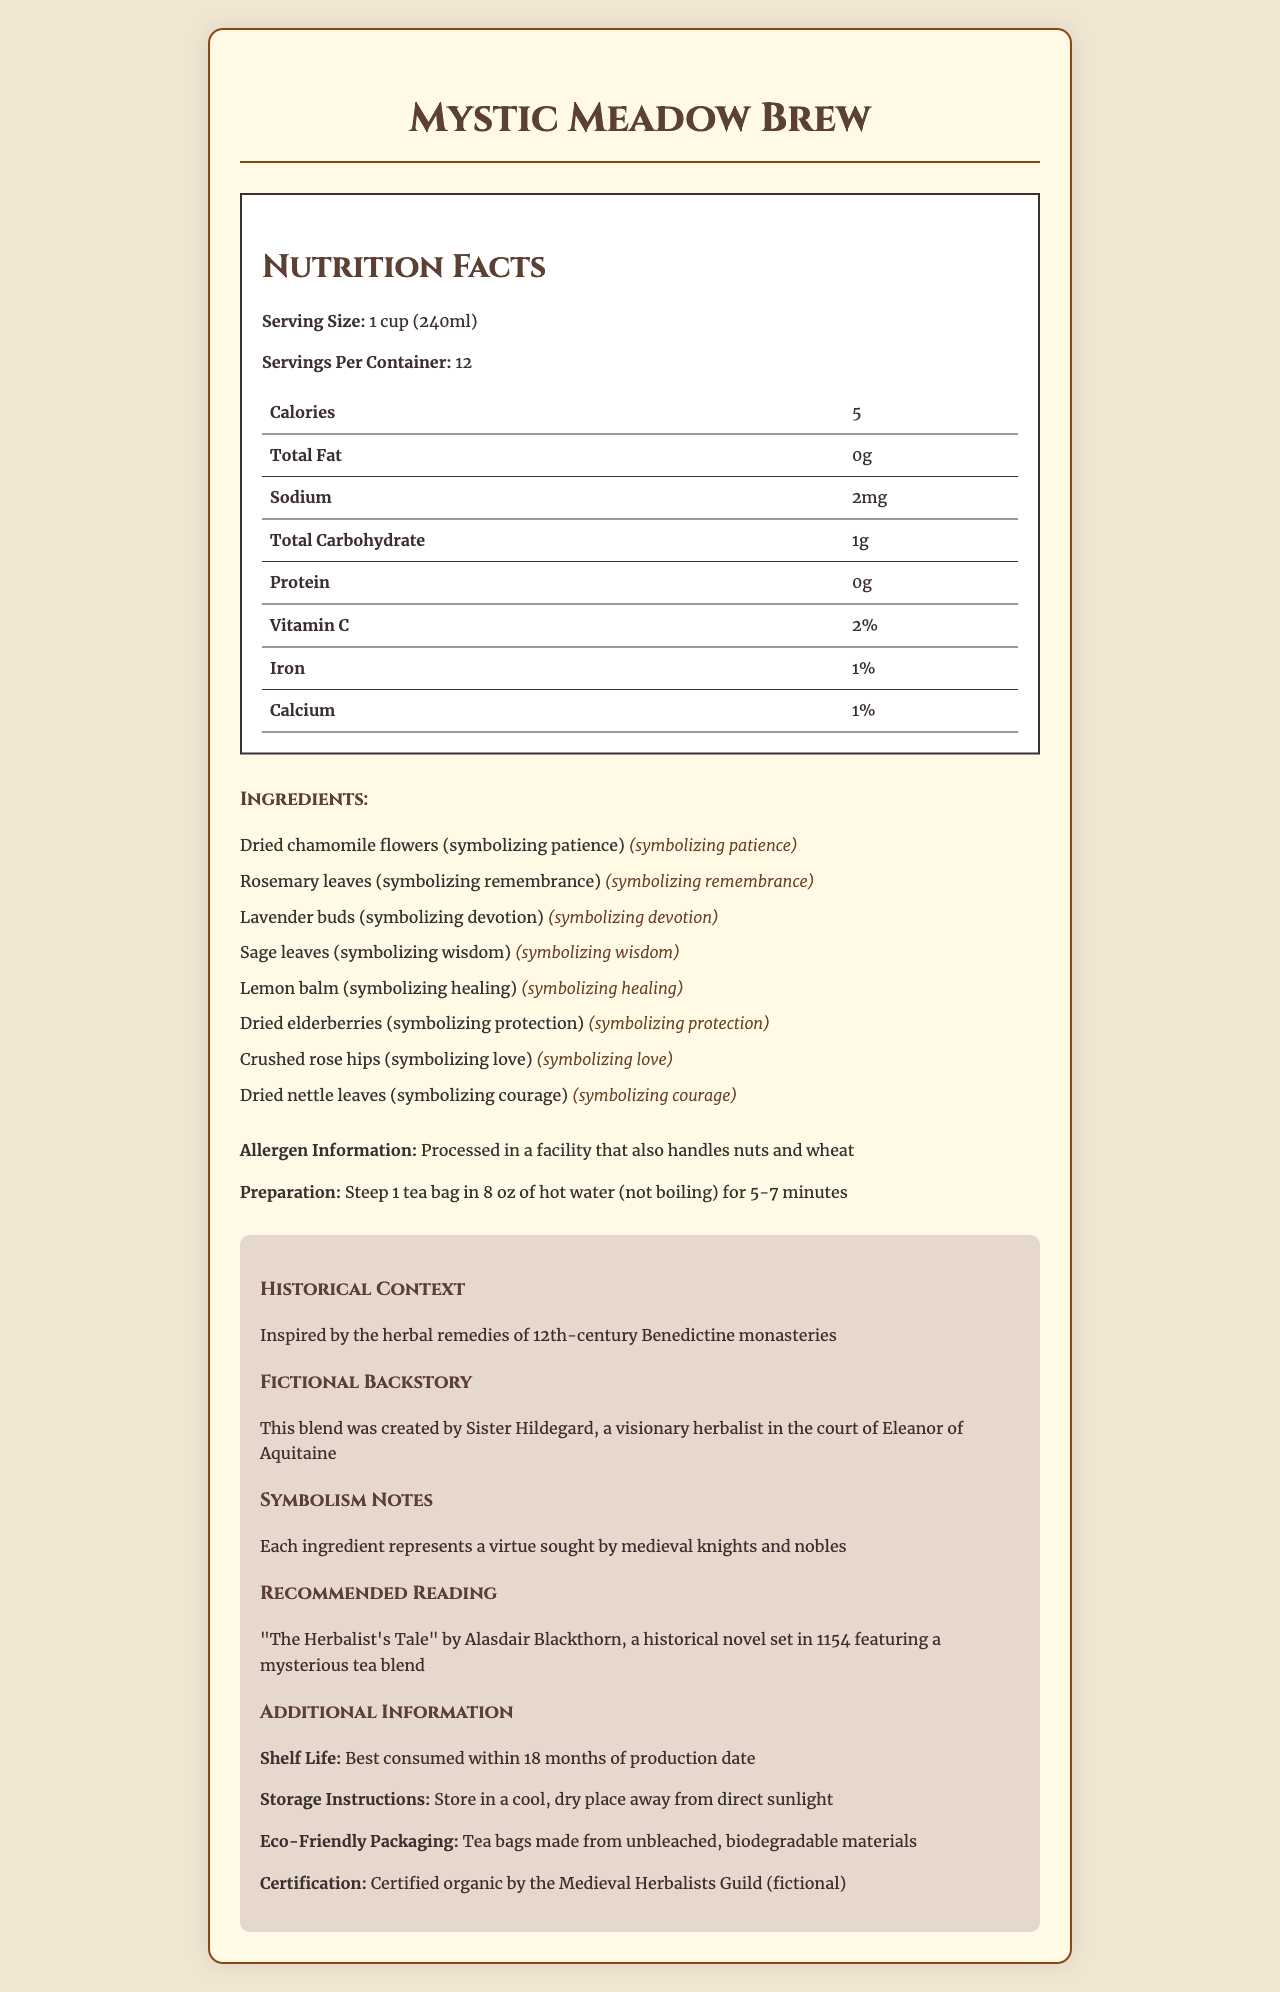what is the product name? The product name is mentioned at the top of the document.
Answer: Mystic Meadow Brew how many servings are in one container? The document states that there are 12 servings per container.
Answer: 12 how many calories are in one serving? The document lists 5 calories per serving size of 1 cup (240ml).
Answer: 5 which ingredient symbolizes courage? The ingredient dried nettle leaves are noted to symbolize courage in the ingredients section.
Answer: Dried nettle leaves what certification does the product have? The certification is mentioned under "Additional Information."
Answer: Certified organic by the Medieval Herbalists Guild (fictional) what is the preparation method for the tea? The preparation method is described in the preparation section.
Answer: Steep 1 tea bag in 8 oz of hot water (not boiling) for 5-7 minutes what nutrient is present in the highest percentage of daily value per serving? A. Sodium B. Vitamin C C. Iron Vitamin C is present at 2% daily value per serving, which is stated specifically in the nutrition table.
Answer: B. Vitamin C which of the following ingredients is not included in the tea blend? A. Lemon balm B. Lavender buds C. Mint leaves D. Chamomile flowers Mint leaves are not listed among the ingredients; the others are.
Answer: C. Mint leaves is the product eco-friendly? The document mentions that the tea bags are made from unbleached, biodegradable materials.
Answer: Yes describe the historical context and fictional backstory of the product. The historical context and fictional backstory are described in the "Historical Context" and "Fictional Backstory" sections.
Answer: The Mystic Meadow Brew is inspired by the herbal remedies of 12th-century Benedictine monasteries and was created by Sister Hildegard, a visionary herbalist in the court of Eleanor of Aquitaine. what is the recommended shelf life of the tea? The document states the best consumption period is within 18 months of production date.
Answer: 18 months where should the tea be stored? The storage instructions specify to store the product in a cool, dry place away from direct sunlight.
Answer: In a cool, dry place away from direct sunlight how is the symbolism of the ingredients explained? The symbolism notes section mentions that each ingredient symbolizes virtues sought by medieval knights and nobles.
Answer: Each ingredient represents a virtue sought by medieval knights and nobles what is the book recommended for readers to complement the tea? The recommended book is specified in the "Recommended Reading" section.
Answer: "The Herbalist's Tale" by Alasdair Blackthorn Can the product be considered suitable for someone with a nut allergy? The allergen info mentions that it is processed in a facility that also handles nuts and wheat, which does not confirm whether it is entirely safe for someone with a nut allergy.
Answer: Not enough information Summarize the entire document. The summary covers the various sections of the document, highlighting the main points and detailed information presented.
Answer: The document describes "Mystic Meadow Brew," a herbal tea inspired by 12th-century Benedictine remedies, created with symbolic ingredients. It includes nutrition facts, preparation method, ingredients, allergen info, historical context, fictional backstory, symbolism notes, recommended reading, shelf life, storage instructions, eco-friendly packaging, and certification. 